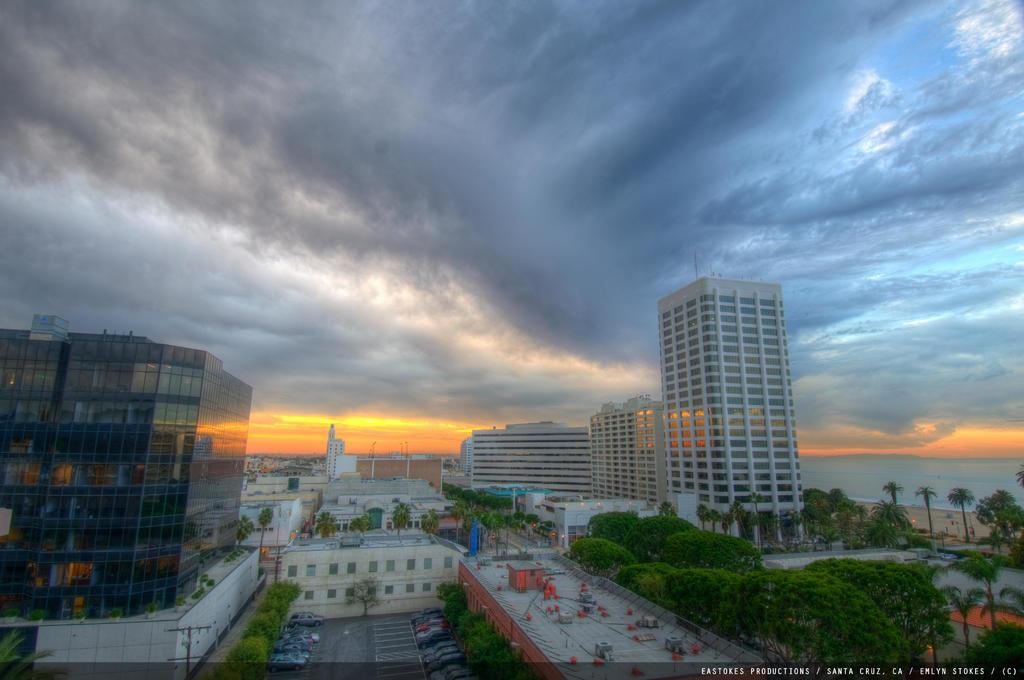What can be seen on the path in the image? There are vehicles parked on the path in the image. What type of structures are present in the image? There are buildings in the image. What type of vegetation is visible in the image? There are trees in the image. What natural element is visible in the image? There is water visible in the image. What is visible in the background of the image? The sky is visible in the background of the image. How much money is being exchanged between the trees in the image? There is no money being exchanged in the image; it features vehicles, buildings, trees, water, and the sky. What type of furniture can be seen in the image? There is no furniture present in the image. 